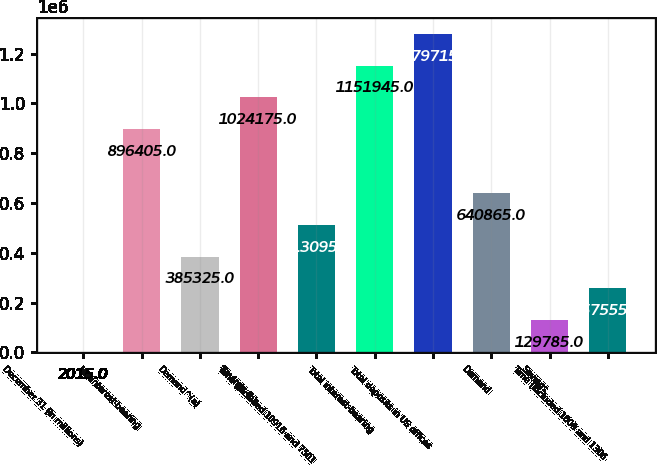Convert chart. <chart><loc_0><loc_0><loc_500><loc_500><bar_chart><fcel>December 31 (in millions)<fcel>Noninterest-bearing<fcel>Demand^(a)<fcel>Savings (b)<fcel>Time (included 10916 and 7501<fcel>Total interest-bearing<fcel>Total deposits in US offices<fcel>Demand<fcel>Savings<fcel>Time (included 1600 and 1306<nl><fcel>2015<fcel>896405<fcel>385325<fcel>1.02418e+06<fcel>513095<fcel>1.15194e+06<fcel>1.27972e+06<fcel>640865<fcel>129785<fcel>257555<nl></chart> 